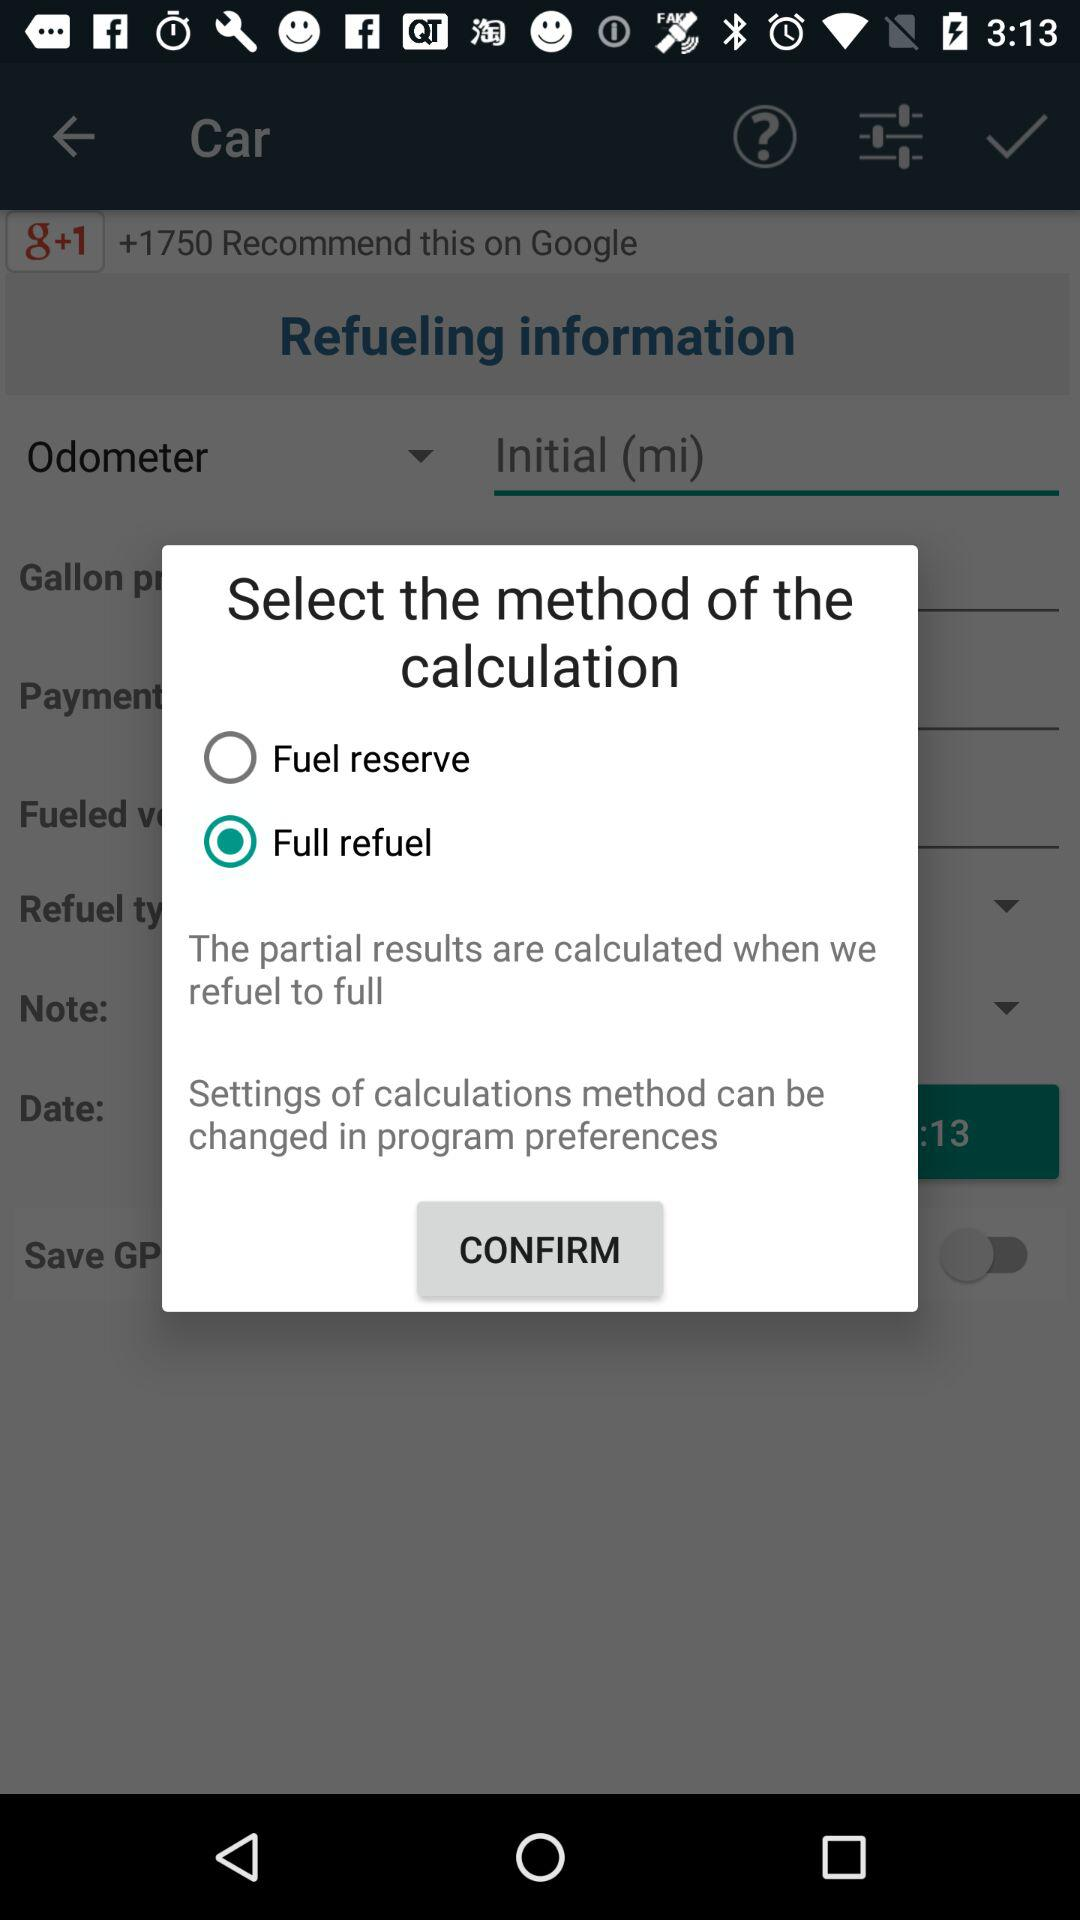How many recommendations are there for the car on "g+1"? For the car, there are more than 1750 recommendations on "g+1". 